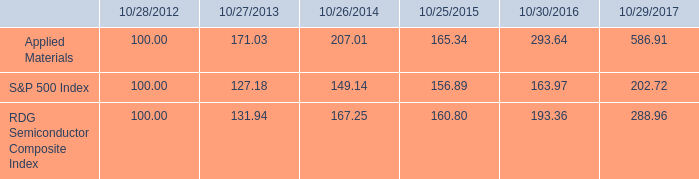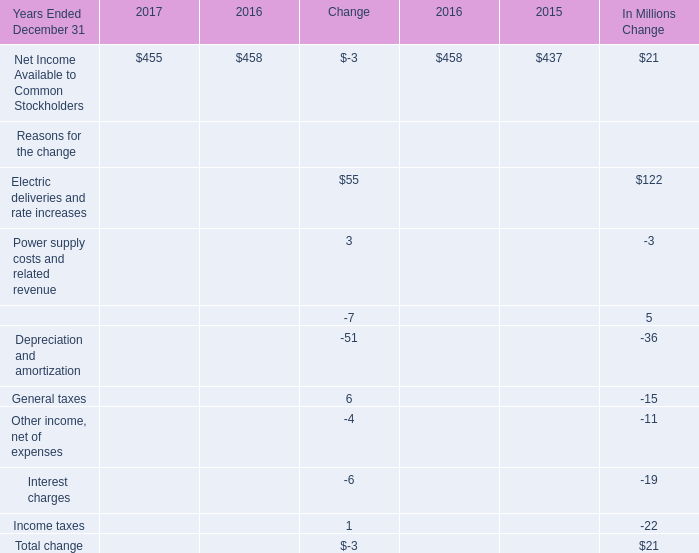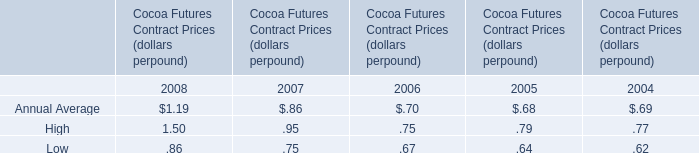What was the total amount of the change between 2016 and 2015 in the range of 0 and 150? (in million) 
Computations: (122 + 5)
Answer: 127.0. 